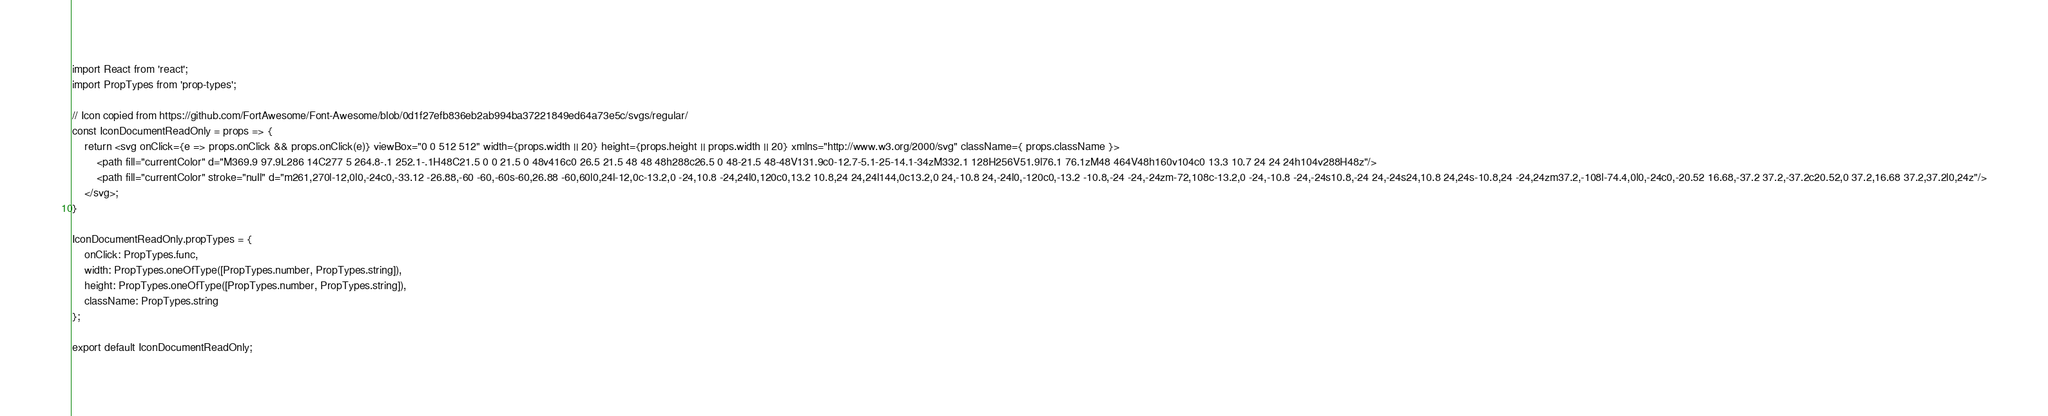Convert code to text. <code><loc_0><loc_0><loc_500><loc_500><_JavaScript_>import React from 'react';
import PropTypes from 'prop-types';

// Icon copied from https://github.com/FortAwesome/Font-Awesome/blob/0d1f27efb836eb2ab994ba37221849ed64a73e5c/svgs/regular/
const IconDocumentReadOnly = props => {
    return <svg onClick={e => props.onClick && props.onClick(e)} viewBox="0 0 512 512" width={props.width || 20} height={props.height || props.width || 20} xmlns="http://www.w3.org/2000/svg" className={ props.className }>
        <path fill="currentColor" d="M369.9 97.9L286 14C277 5 264.8-.1 252.1-.1H48C21.5 0 0 21.5 0 48v416c0 26.5 21.5 48 48 48h288c26.5 0 48-21.5 48-48V131.9c0-12.7-5.1-25-14.1-34zM332.1 128H256V51.9l76.1 76.1zM48 464V48h160v104c0 13.3 10.7 24 24 24h104v288H48z"/>
        <path fill="currentColor" stroke="null" d="m261,270l-12,0l0,-24c0,-33.12 -26.88,-60 -60,-60s-60,26.88 -60,60l0,24l-12,0c-13.2,0 -24,10.8 -24,24l0,120c0,13.2 10.8,24 24,24l144,0c13.2,0 24,-10.8 24,-24l0,-120c0,-13.2 -10.8,-24 -24,-24zm-72,108c-13.2,0 -24,-10.8 -24,-24s10.8,-24 24,-24s24,10.8 24,24s-10.8,24 -24,24zm37.2,-108l-74.4,0l0,-24c0,-20.52 16.68,-37.2 37.2,-37.2c20.52,0 37.2,16.68 37.2,37.2l0,24z"/>
    </svg>;
}

IconDocumentReadOnly.propTypes = {
    onClick: PropTypes.func,
    width: PropTypes.oneOfType([PropTypes.number, PropTypes.string]),
    height: PropTypes.oneOfType([PropTypes.number, PropTypes.string]),
    className: PropTypes.string
};

export default IconDocumentReadOnly;</code> 